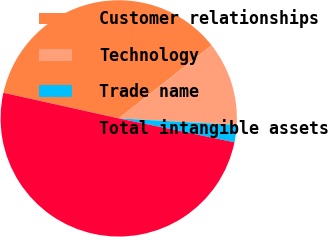Convert chart to OTSL. <chart><loc_0><loc_0><loc_500><loc_500><pie_chart><fcel>Customer relationships<fcel>Technology<fcel>Trade name<fcel>Total intangible assets<nl><fcel>35.91%<fcel>11.5%<fcel>2.36%<fcel>50.24%<nl></chart> 